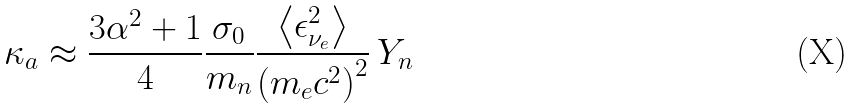Convert formula to latex. <formula><loc_0><loc_0><loc_500><loc_500>\kappa _ { a } \approx { \frac { 3 \alpha ^ { 2 } + 1 } { 4 } } \frac { \sigma _ { 0 } } { m _ { n } } \frac { \left < \epsilon ^ { 2 } _ { \nu _ { e } } \right > } { \left ( m _ { e } c ^ { 2 } \right ) ^ { 2 } } \, Y _ { n }</formula> 